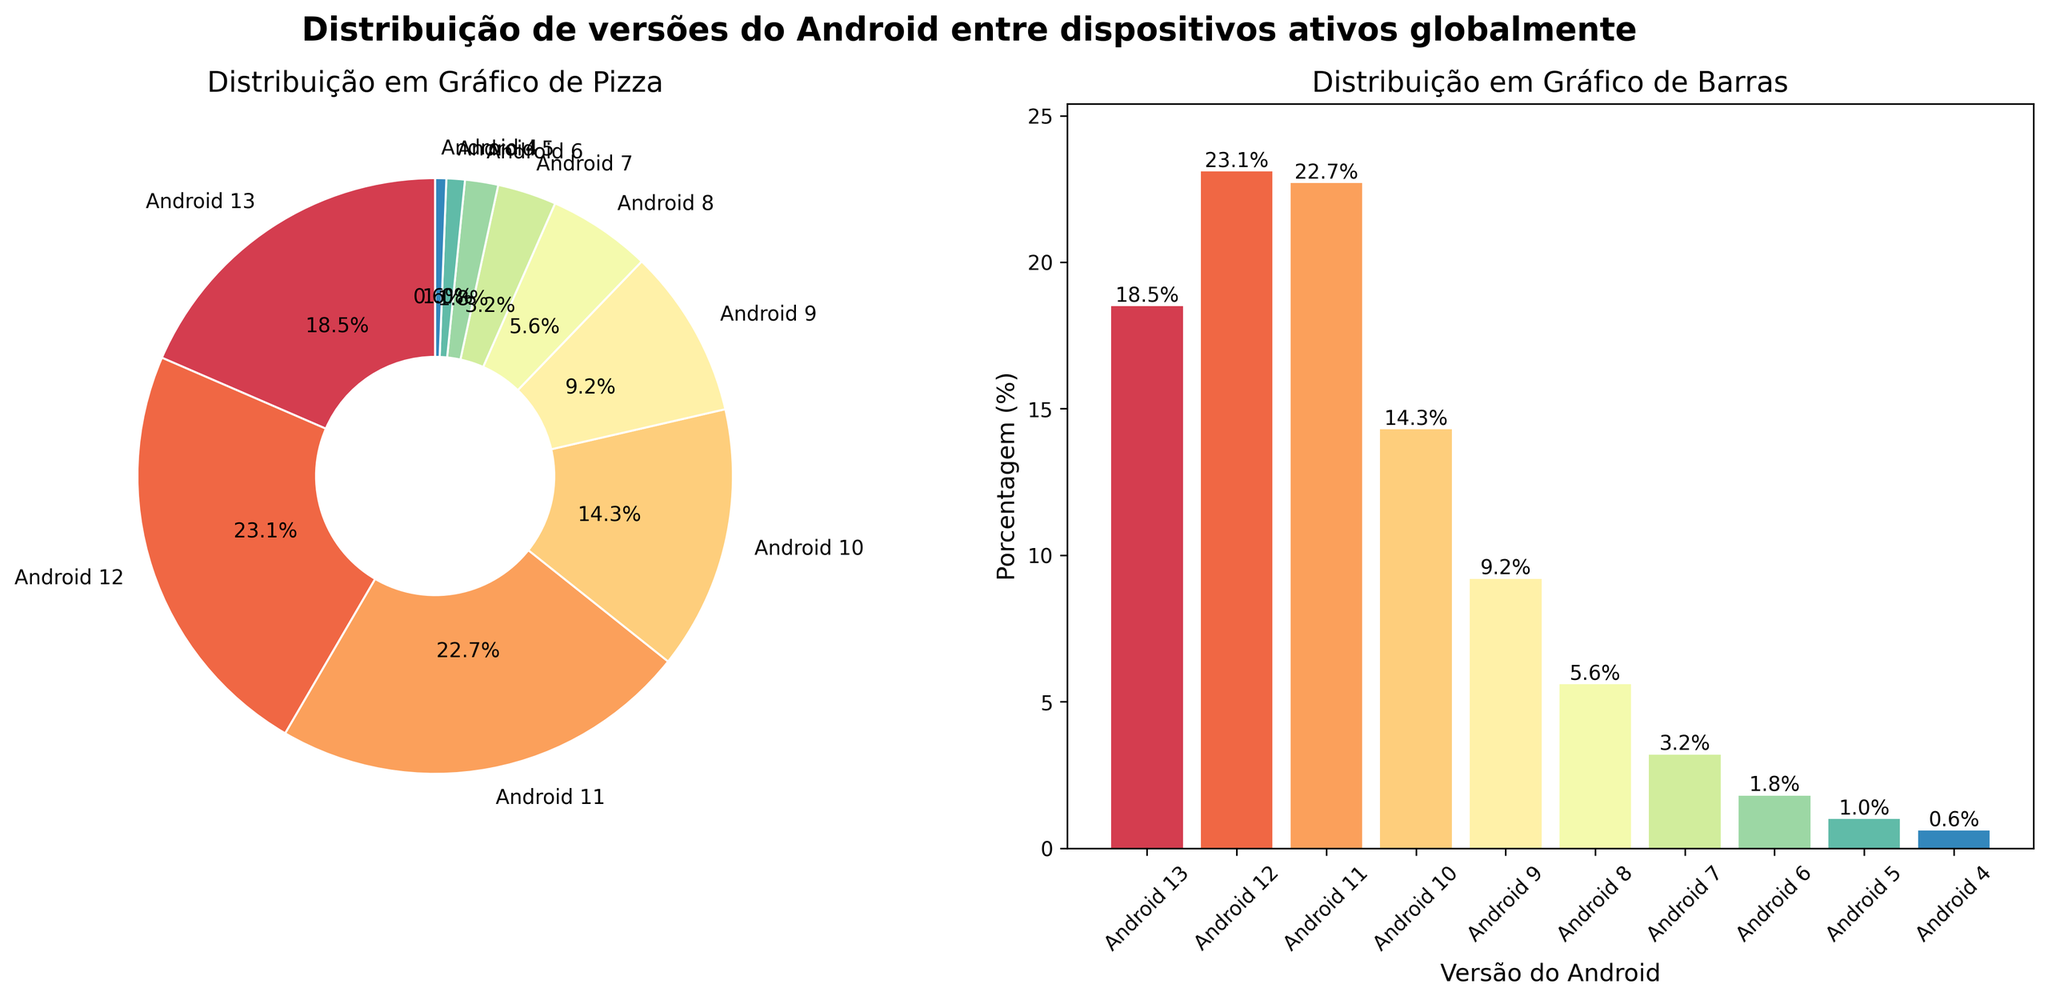What percentage of devices run Android 11? In the pie chart and bar chart, we can see that Android 11 has a slice and bar labeled with its percentage. By looking at the chart, we find that the percentage is 22.7%.
Answer: 22.7% Which Android version is installed on the lowest percentage of devices? By examining both the pie and bar charts, we see that Android 4 has the smallest slice and shortest bar, indicating it has the lowest percentage at 0.6%.
Answer: Android 4 What's the total percentage of devices running Android versions earlier than Android 8? Add the percentages of Android 7, Android 6, Android 5, and Android 4: 3.2% + 1.8% + 1.0% + 0.6% = 6.6%.
Answer: 6.6% Which version has the highest distribution among devices? By looking at both the pie and bar charts, it's clear that Android 12 has the largest slice and tallest bar, showing it has the highest percentage at 23.1%.
Answer: Android 12 Is the percentage of devices running Android 10 greater than the sum of those running Android 9 and Android 8? Compare Android 10's percentage (14.3%) with the sum of Android 9 and Android 8 (9.2% + 5.6% = 14.8%). Since 14.3% is less than 14.8%, the statement is false.
Answer: No What is the percentage difference between Android 12 and Android 11 distributions? Subtract Android 11's percentage from Android 12's: 23.1% - 22.7% = 0.4%.
Answer: 0.4% How much higher is the percentage of Android 13 compared to Android 9? Subtract Android 9's percentage from Android 13's: 18.5% - 9.2% = 9.3%.
Answer: 9.3% Which versions have percentages that are greater than 20%? By looking at the bars and pie slices, we can see that both Android 12 (23.1%) and Android 11 (22.7%) have percentages greater than 20%.
Answer: Android 12, Android 11 What is the combined percentage of devices running Android 13, 12, and 11? Add the percentages for Android 13, Android 12, and Android 11: 18.5% + 23.1% + 22.7% = 64.3%.
Answer: 64.3% 